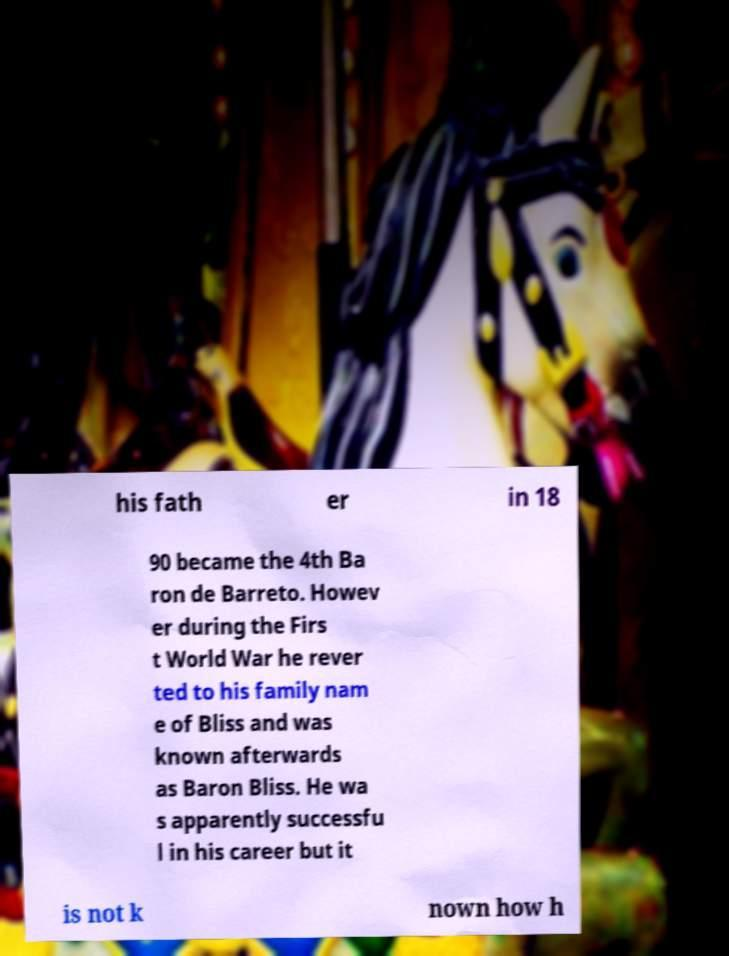I need the written content from this picture converted into text. Can you do that? his fath er in 18 90 became the 4th Ba ron de Barreto. Howev er during the Firs t World War he rever ted to his family nam e of Bliss and was known afterwards as Baron Bliss. He wa s apparently successfu l in his career but it is not k nown how h 